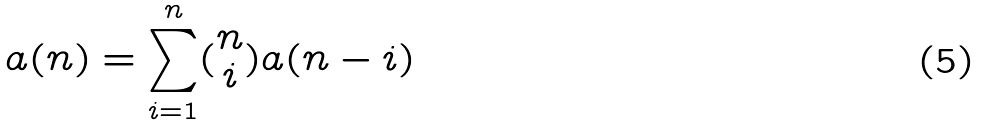<formula> <loc_0><loc_0><loc_500><loc_500>a ( n ) = \sum _ { i = 1 } ^ { n } ( \begin{matrix} n \\ i \end{matrix} ) a ( n - i )</formula> 